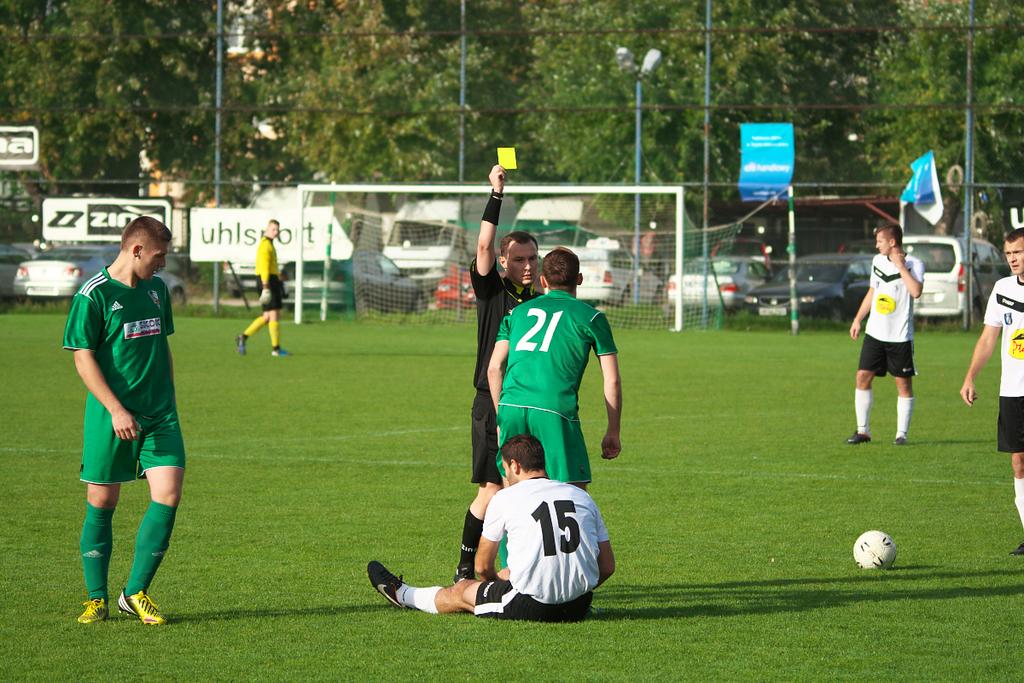What is the green teammates jersey number?
Keep it short and to the point. 21. What is the man in whites jersey number?
Your answer should be very brief. 15. 